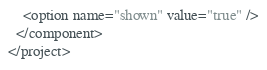Convert code to text. <code><loc_0><loc_0><loc_500><loc_500><_XML_>    <option name="shown" value="true" />
  </component>
</project></code> 